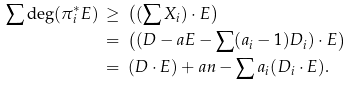<formula> <loc_0><loc_0><loc_500><loc_500>\sum \deg ( \pi _ { i } ^ { * } E ) \, & \geq \, \left ( ( \sum X _ { i } ) \cdot E \right ) \\ & = \, \left ( ( D - a E - \sum ( a _ { i } - 1 ) D _ { i } ) \cdot E \right ) \\ & = \, ( D \cdot E ) + a n - \sum a _ { i } ( D _ { i } \cdot E ) .</formula> 